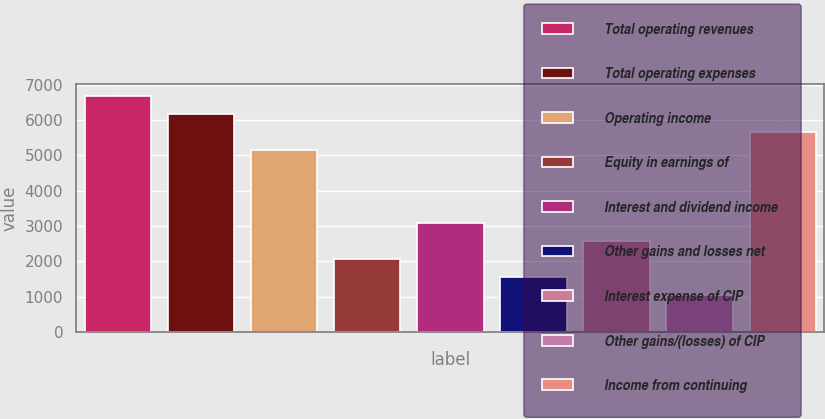<chart> <loc_0><loc_0><loc_500><loc_500><bar_chart><fcel>Total operating revenues<fcel>Total operating expenses<fcel>Operating income<fcel>Equity in earnings of<fcel>Interest and dividend income<fcel>Other gains and losses net<fcel>Interest expense of CIP<fcel>Other gains/(losses) of CIP<fcel>Income from continuing<nl><fcel>6687.33<fcel>6173.92<fcel>5147.1<fcel>2066.64<fcel>3093.46<fcel>1553.23<fcel>2580.05<fcel>1039.82<fcel>5660.51<nl></chart> 